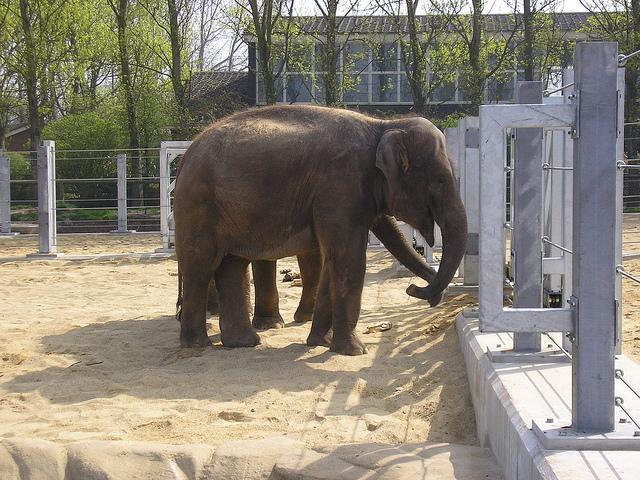What are the elephants standing in?
Pick the right solution, then justify: 'Answer: answer
Rationale: rationale.'
Options: Sand, mud, woodchips, grass. Answer: sand.
Rationale: This footing is good for drainage of animal urine. 